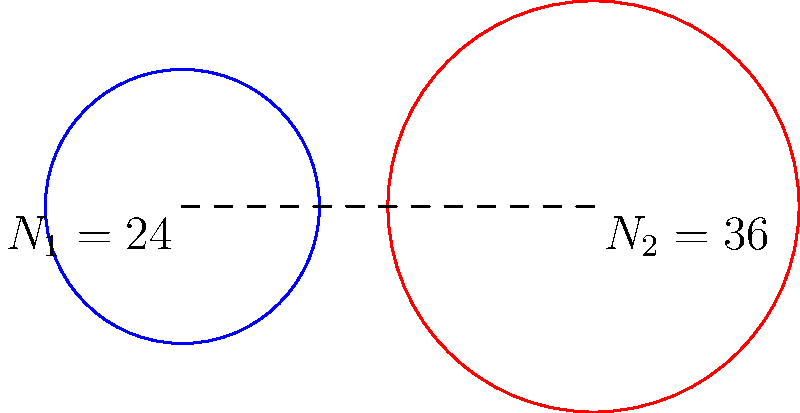In the simple gear train shown, gear 1 (blue) has 24 teeth and gear 2 (red) has 36 teeth. If gear 1 rotates at 120 rpm clockwise, what is the speed and direction of rotation of gear 2? To solve this problem, we'll follow these steps:

1. Determine the gear ratio:
   The gear ratio is given by the number of teeth on the driven gear divided by the number of teeth on the driving gear.
   $$\text{Gear Ratio} = \frac{N_2}{N_1} = \frac{36}{24} = 1.5$$

2. Calculate the speed of gear 2:
   The speed of gear 2 is inversely proportional to the gear ratio.
   $$\text{Speed of gear 2} = \frac{\text{Speed of gear 1}}{\text{Gear Ratio}} = \frac{120 \text{ rpm}}{1.5} = 80 \text{ rpm}$$

3. Determine the direction of rotation:
   In a simple gear train with two gears, the gears rotate in opposite directions. Since gear 1 rotates clockwise, gear 2 will rotate counterclockwise.

Therefore, gear 2 will rotate at 80 rpm counterclockwise.
Answer: 80 rpm counterclockwise 